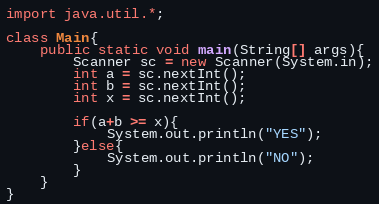Convert code to text. <code><loc_0><loc_0><loc_500><loc_500><_Java_>import java.util.*;

class Main{
    public static void main(String[] args){
        Scanner sc = new Scanner(System.in);
        int a = sc.nextInt();
        int b = sc.nextInt();
        int x = sc.nextInt();

        if(a+b >= x){
            System.out.println("YES");
        }else{
            System.out.println("NO");
        }
    }
}</code> 